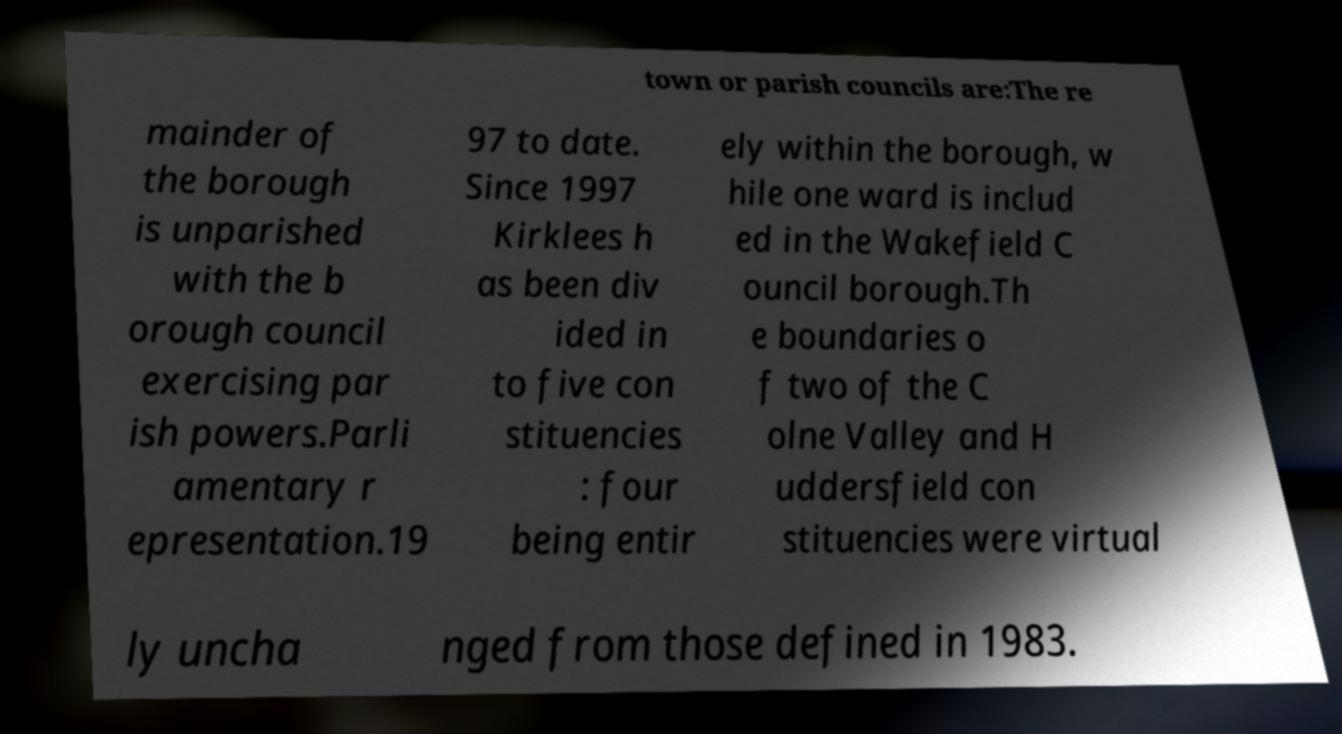Can you accurately transcribe the text from the provided image for me? town or parish councils are:The re mainder of the borough is unparished with the b orough council exercising par ish powers.Parli amentary r epresentation.19 97 to date. Since 1997 Kirklees h as been div ided in to five con stituencies : four being entir ely within the borough, w hile one ward is includ ed in the Wakefield C ouncil borough.Th e boundaries o f two of the C olne Valley and H uddersfield con stituencies were virtual ly uncha nged from those defined in 1983. 